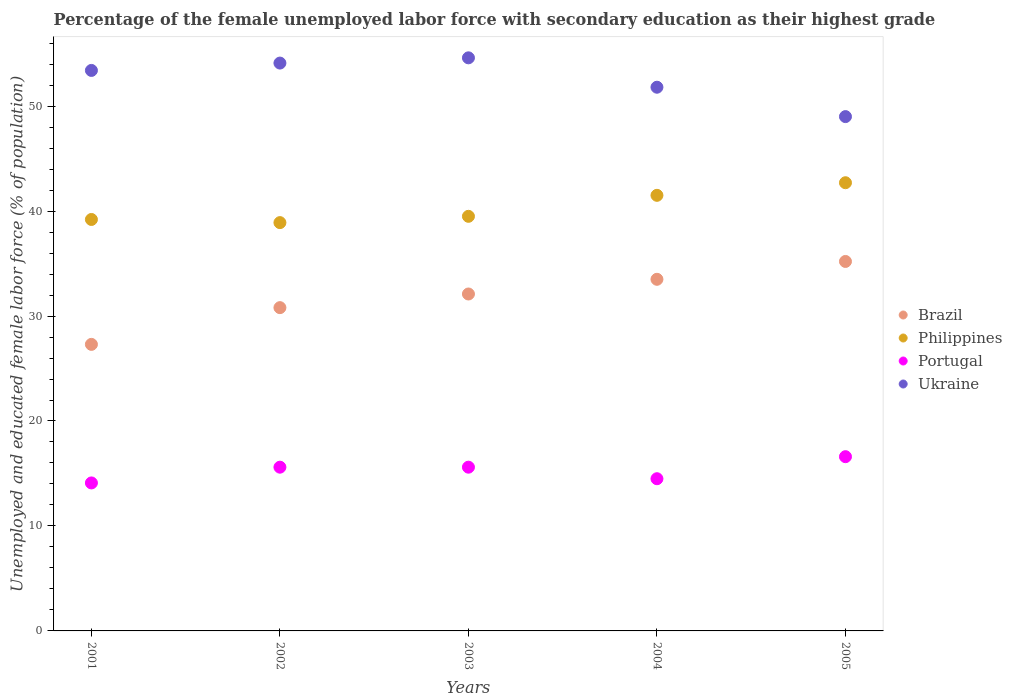How many different coloured dotlines are there?
Your answer should be compact. 4. Is the number of dotlines equal to the number of legend labels?
Provide a short and direct response. Yes. What is the percentage of the unemployed female labor force with secondary education in Philippines in 2005?
Provide a succinct answer. 42.7. Across all years, what is the maximum percentage of the unemployed female labor force with secondary education in Philippines?
Ensure brevity in your answer.  42.7. Across all years, what is the minimum percentage of the unemployed female labor force with secondary education in Brazil?
Ensure brevity in your answer.  27.3. In which year was the percentage of the unemployed female labor force with secondary education in Brazil minimum?
Provide a succinct answer. 2001. What is the total percentage of the unemployed female labor force with secondary education in Philippines in the graph?
Keep it short and to the point. 201.8. What is the difference between the percentage of the unemployed female labor force with secondary education in Portugal in 2003 and that in 2005?
Your answer should be compact. -1. What is the difference between the percentage of the unemployed female labor force with secondary education in Brazil in 2004 and the percentage of the unemployed female labor force with secondary education in Portugal in 2003?
Keep it short and to the point. 17.9. What is the average percentage of the unemployed female labor force with secondary education in Ukraine per year?
Ensure brevity in your answer.  52.58. In the year 2002, what is the difference between the percentage of the unemployed female labor force with secondary education in Portugal and percentage of the unemployed female labor force with secondary education in Philippines?
Your answer should be compact. -23.3. In how many years, is the percentage of the unemployed female labor force with secondary education in Brazil greater than 50 %?
Give a very brief answer. 0. What is the ratio of the percentage of the unemployed female labor force with secondary education in Ukraine in 2003 to that in 2004?
Your answer should be very brief. 1.05. Is the difference between the percentage of the unemployed female labor force with secondary education in Portugal in 2002 and 2003 greater than the difference between the percentage of the unemployed female labor force with secondary education in Philippines in 2002 and 2003?
Keep it short and to the point. Yes. What is the difference between the highest and the second highest percentage of the unemployed female labor force with secondary education in Brazil?
Make the answer very short. 1.7. What is the difference between the highest and the lowest percentage of the unemployed female labor force with secondary education in Brazil?
Make the answer very short. 7.9. Is it the case that in every year, the sum of the percentage of the unemployed female labor force with secondary education in Ukraine and percentage of the unemployed female labor force with secondary education in Brazil  is greater than the sum of percentage of the unemployed female labor force with secondary education in Philippines and percentage of the unemployed female labor force with secondary education in Portugal?
Your answer should be compact. Yes. Is it the case that in every year, the sum of the percentage of the unemployed female labor force with secondary education in Ukraine and percentage of the unemployed female labor force with secondary education in Philippines  is greater than the percentage of the unemployed female labor force with secondary education in Brazil?
Offer a very short reply. Yes. Does the percentage of the unemployed female labor force with secondary education in Portugal monotonically increase over the years?
Provide a short and direct response. No. Is the percentage of the unemployed female labor force with secondary education in Ukraine strictly greater than the percentage of the unemployed female labor force with secondary education in Portugal over the years?
Offer a terse response. Yes. Is the percentage of the unemployed female labor force with secondary education in Portugal strictly less than the percentage of the unemployed female labor force with secondary education in Brazil over the years?
Provide a succinct answer. Yes. How many years are there in the graph?
Make the answer very short. 5. What is the difference between two consecutive major ticks on the Y-axis?
Your answer should be compact. 10. Are the values on the major ticks of Y-axis written in scientific E-notation?
Your response must be concise. No. How many legend labels are there?
Give a very brief answer. 4. How are the legend labels stacked?
Provide a succinct answer. Vertical. What is the title of the graph?
Provide a short and direct response. Percentage of the female unemployed labor force with secondary education as their highest grade. Does "Virgin Islands" appear as one of the legend labels in the graph?
Provide a succinct answer. No. What is the label or title of the X-axis?
Provide a short and direct response. Years. What is the label or title of the Y-axis?
Make the answer very short. Unemployed and educated female labor force (% of population). What is the Unemployed and educated female labor force (% of population) of Brazil in 2001?
Keep it short and to the point. 27.3. What is the Unemployed and educated female labor force (% of population) in Philippines in 2001?
Offer a terse response. 39.2. What is the Unemployed and educated female labor force (% of population) of Portugal in 2001?
Provide a succinct answer. 14.1. What is the Unemployed and educated female labor force (% of population) in Ukraine in 2001?
Provide a short and direct response. 53.4. What is the Unemployed and educated female labor force (% of population) of Brazil in 2002?
Offer a terse response. 30.8. What is the Unemployed and educated female labor force (% of population) in Philippines in 2002?
Your answer should be very brief. 38.9. What is the Unemployed and educated female labor force (% of population) of Portugal in 2002?
Your response must be concise. 15.6. What is the Unemployed and educated female labor force (% of population) in Ukraine in 2002?
Offer a very short reply. 54.1. What is the Unemployed and educated female labor force (% of population) in Brazil in 2003?
Your response must be concise. 32.1. What is the Unemployed and educated female labor force (% of population) of Philippines in 2003?
Provide a succinct answer. 39.5. What is the Unemployed and educated female labor force (% of population) of Portugal in 2003?
Keep it short and to the point. 15.6. What is the Unemployed and educated female labor force (% of population) of Ukraine in 2003?
Keep it short and to the point. 54.6. What is the Unemployed and educated female labor force (% of population) of Brazil in 2004?
Keep it short and to the point. 33.5. What is the Unemployed and educated female labor force (% of population) in Philippines in 2004?
Offer a very short reply. 41.5. What is the Unemployed and educated female labor force (% of population) in Portugal in 2004?
Offer a very short reply. 14.5. What is the Unemployed and educated female labor force (% of population) in Ukraine in 2004?
Offer a terse response. 51.8. What is the Unemployed and educated female labor force (% of population) of Brazil in 2005?
Give a very brief answer. 35.2. What is the Unemployed and educated female labor force (% of population) in Philippines in 2005?
Offer a very short reply. 42.7. What is the Unemployed and educated female labor force (% of population) of Portugal in 2005?
Give a very brief answer. 16.6. Across all years, what is the maximum Unemployed and educated female labor force (% of population) in Brazil?
Keep it short and to the point. 35.2. Across all years, what is the maximum Unemployed and educated female labor force (% of population) in Philippines?
Your answer should be compact. 42.7. Across all years, what is the maximum Unemployed and educated female labor force (% of population) in Portugal?
Offer a terse response. 16.6. Across all years, what is the maximum Unemployed and educated female labor force (% of population) in Ukraine?
Offer a terse response. 54.6. Across all years, what is the minimum Unemployed and educated female labor force (% of population) of Brazil?
Your response must be concise. 27.3. Across all years, what is the minimum Unemployed and educated female labor force (% of population) in Philippines?
Your answer should be very brief. 38.9. Across all years, what is the minimum Unemployed and educated female labor force (% of population) in Portugal?
Give a very brief answer. 14.1. What is the total Unemployed and educated female labor force (% of population) of Brazil in the graph?
Your answer should be very brief. 158.9. What is the total Unemployed and educated female labor force (% of population) of Philippines in the graph?
Offer a terse response. 201.8. What is the total Unemployed and educated female labor force (% of population) in Portugal in the graph?
Offer a very short reply. 76.4. What is the total Unemployed and educated female labor force (% of population) of Ukraine in the graph?
Provide a short and direct response. 262.9. What is the difference between the Unemployed and educated female labor force (% of population) in Brazil in 2001 and that in 2002?
Offer a very short reply. -3.5. What is the difference between the Unemployed and educated female labor force (% of population) in Portugal in 2001 and that in 2002?
Make the answer very short. -1.5. What is the difference between the Unemployed and educated female labor force (% of population) of Ukraine in 2001 and that in 2002?
Offer a terse response. -0.7. What is the difference between the Unemployed and educated female labor force (% of population) in Philippines in 2001 and that in 2003?
Your answer should be compact. -0.3. What is the difference between the Unemployed and educated female labor force (% of population) of Portugal in 2001 and that in 2003?
Give a very brief answer. -1.5. What is the difference between the Unemployed and educated female labor force (% of population) of Philippines in 2001 and that in 2004?
Keep it short and to the point. -2.3. What is the difference between the Unemployed and educated female labor force (% of population) of Ukraine in 2001 and that in 2004?
Offer a terse response. 1.6. What is the difference between the Unemployed and educated female labor force (% of population) of Portugal in 2001 and that in 2005?
Your answer should be compact. -2.5. What is the difference between the Unemployed and educated female labor force (% of population) of Ukraine in 2001 and that in 2005?
Give a very brief answer. 4.4. What is the difference between the Unemployed and educated female labor force (% of population) of Brazil in 2002 and that in 2003?
Offer a terse response. -1.3. What is the difference between the Unemployed and educated female labor force (% of population) of Portugal in 2002 and that in 2004?
Keep it short and to the point. 1.1. What is the difference between the Unemployed and educated female labor force (% of population) of Philippines in 2002 and that in 2005?
Make the answer very short. -3.8. What is the difference between the Unemployed and educated female labor force (% of population) in Brazil in 2003 and that in 2004?
Provide a short and direct response. -1.4. What is the difference between the Unemployed and educated female labor force (% of population) of Philippines in 2003 and that in 2004?
Ensure brevity in your answer.  -2. What is the difference between the Unemployed and educated female labor force (% of population) of Ukraine in 2003 and that in 2004?
Make the answer very short. 2.8. What is the difference between the Unemployed and educated female labor force (% of population) in Brazil in 2003 and that in 2005?
Keep it short and to the point. -3.1. What is the difference between the Unemployed and educated female labor force (% of population) in Philippines in 2004 and that in 2005?
Your answer should be compact. -1.2. What is the difference between the Unemployed and educated female labor force (% of population) of Brazil in 2001 and the Unemployed and educated female labor force (% of population) of Portugal in 2002?
Offer a very short reply. 11.7. What is the difference between the Unemployed and educated female labor force (% of population) in Brazil in 2001 and the Unemployed and educated female labor force (% of population) in Ukraine in 2002?
Provide a succinct answer. -26.8. What is the difference between the Unemployed and educated female labor force (% of population) of Philippines in 2001 and the Unemployed and educated female labor force (% of population) of Portugal in 2002?
Your answer should be very brief. 23.6. What is the difference between the Unemployed and educated female labor force (% of population) of Philippines in 2001 and the Unemployed and educated female labor force (% of population) of Ukraine in 2002?
Give a very brief answer. -14.9. What is the difference between the Unemployed and educated female labor force (% of population) of Portugal in 2001 and the Unemployed and educated female labor force (% of population) of Ukraine in 2002?
Your answer should be compact. -40. What is the difference between the Unemployed and educated female labor force (% of population) in Brazil in 2001 and the Unemployed and educated female labor force (% of population) in Portugal in 2003?
Offer a very short reply. 11.7. What is the difference between the Unemployed and educated female labor force (% of population) in Brazil in 2001 and the Unemployed and educated female labor force (% of population) in Ukraine in 2003?
Your answer should be very brief. -27.3. What is the difference between the Unemployed and educated female labor force (% of population) in Philippines in 2001 and the Unemployed and educated female labor force (% of population) in Portugal in 2003?
Ensure brevity in your answer.  23.6. What is the difference between the Unemployed and educated female labor force (% of population) in Philippines in 2001 and the Unemployed and educated female labor force (% of population) in Ukraine in 2003?
Give a very brief answer. -15.4. What is the difference between the Unemployed and educated female labor force (% of population) in Portugal in 2001 and the Unemployed and educated female labor force (% of population) in Ukraine in 2003?
Offer a terse response. -40.5. What is the difference between the Unemployed and educated female labor force (% of population) of Brazil in 2001 and the Unemployed and educated female labor force (% of population) of Ukraine in 2004?
Give a very brief answer. -24.5. What is the difference between the Unemployed and educated female labor force (% of population) of Philippines in 2001 and the Unemployed and educated female labor force (% of population) of Portugal in 2004?
Ensure brevity in your answer.  24.7. What is the difference between the Unemployed and educated female labor force (% of population) of Portugal in 2001 and the Unemployed and educated female labor force (% of population) of Ukraine in 2004?
Keep it short and to the point. -37.7. What is the difference between the Unemployed and educated female labor force (% of population) of Brazil in 2001 and the Unemployed and educated female labor force (% of population) of Philippines in 2005?
Offer a very short reply. -15.4. What is the difference between the Unemployed and educated female labor force (% of population) of Brazil in 2001 and the Unemployed and educated female labor force (% of population) of Portugal in 2005?
Give a very brief answer. 10.7. What is the difference between the Unemployed and educated female labor force (% of population) of Brazil in 2001 and the Unemployed and educated female labor force (% of population) of Ukraine in 2005?
Keep it short and to the point. -21.7. What is the difference between the Unemployed and educated female labor force (% of population) of Philippines in 2001 and the Unemployed and educated female labor force (% of population) of Portugal in 2005?
Make the answer very short. 22.6. What is the difference between the Unemployed and educated female labor force (% of population) in Philippines in 2001 and the Unemployed and educated female labor force (% of population) in Ukraine in 2005?
Offer a terse response. -9.8. What is the difference between the Unemployed and educated female labor force (% of population) in Portugal in 2001 and the Unemployed and educated female labor force (% of population) in Ukraine in 2005?
Make the answer very short. -34.9. What is the difference between the Unemployed and educated female labor force (% of population) of Brazil in 2002 and the Unemployed and educated female labor force (% of population) of Ukraine in 2003?
Your answer should be compact. -23.8. What is the difference between the Unemployed and educated female labor force (% of population) of Philippines in 2002 and the Unemployed and educated female labor force (% of population) of Portugal in 2003?
Provide a succinct answer. 23.3. What is the difference between the Unemployed and educated female labor force (% of population) of Philippines in 2002 and the Unemployed and educated female labor force (% of population) of Ukraine in 2003?
Make the answer very short. -15.7. What is the difference between the Unemployed and educated female labor force (% of population) of Portugal in 2002 and the Unemployed and educated female labor force (% of population) of Ukraine in 2003?
Keep it short and to the point. -39. What is the difference between the Unemployed and educated female labor force (% of population) of Brazil in 2002 and the Unemployed and educated female labor force (% of population) of Philippines in 2004?
Offer a terse response. -10.7. What is the difference between the Unemployed and educated female labor force (% of population) in Brazil in 2002 and the Unemployed and educated female labor force (% of population) in Portugal in 2004?
Provide a short and direct response. 16.3. What is the difference between the Unemployed and educated female labor force (% of population) in Philippines in 2002 and the Unemployed and educated female labor force (% of population) in Portugal in 2004?
Provide a succinct answer. 24.4. What is the difference between the Unemployed and educated female labor force (% of population) of Portugal in 2002 and the Unemployed and educated female labor force (% of population) of Ukraine in 2004?
Offer a terse response. -36.2. What is the difference between the Unemployed and educated female labor force (% of population) in Brazil in 2002 and the Unemployed and educated female labor force (% of population) in Portugal in 2005?
Your answer should be compact. 14.2. What is the difference between the Unemployed and educated female labor force (% of population) in Brazil in 2002 and the Unemployed and educated female labor force (% of population) in Ukraine in 2005?
Provide a succinct answer. -18.2. What is the difference between the Unemployed and educated female labor force (% of population) in Philippines in 2002 and the Unemployed and educated female labor force (% of population) in Portugal in 2005?
Provide a succinct answer. 22.3. What is the difference between the Unemployed and educated female labor force (% of population) in Philippines in 2002 and the Unemployed and educated female labor force (% of population) in Ukraine in 2005?
Give a very brief answer. -10.1. What is the difference between the Unemployed and educated female labor force (% of population) of Portugal in 2002 and the Unemployed and educated female labor force (% of population) of Ukraine in 2005?
Your answer should be very brief. -33.4. What is the difference between the Unemployed and educated female labor force (% of population) of Brazil in 2003 and the Unemployed and educated female labor force (% of population) of Portugal in 2004?
Your response must be concise. 17.6. What is the difference between the Unemployed and educated female labor force (% of population) of Brazil in 2003 and the Unemployed and educated female labor force (% of population) of Ukraine in 2004?
Your answer should be compact. -19.7. What is the difference between the Unemployed and educated female labor force (% of population) of Philippines in 2003 and the Unemployed and educated female labor force (% of population) of Ukraine in 2004?
Offer a very short reply. -12.3. What is the difference between the Unemployed and educated female labor force (% of population) of Portugal in 2003 and the Unemployed and educated female labor force (% of population) of Ukraine in 2004?
Ensure brevity in your answer.  -36.2. What is the difference between the Unemployed and educated female labor force (% of population) in Brazil in 2003 and the Unemployed and educated female labor force (% of population) in Ukraine in 2005?
Ensure brevity in your answer.  -16.9. What is the difference between the Unemployed and educated female labor force (% of population) of Philippines in 2003 and the Unemployed and educated female labor force (% of population) of Portugal in 2005?
Provide a short and direct response. 22.9. What is the difference between the Unemployed and educated female labor force (% of population) of Portugal in 2003 and the Unemployed and educated female labor force (% of population) of Ukraine in 2005?
Offer a terse response. -33.4. What is the difference between the Unemployed and educated female labor force (% of population) in Brazil in 2004 and the Unemployed and educated female labor force (% of population) in Portugal in 2005?
Offer a very short reply. 16.9. What is the difference between the Unemployed and educated female labor force (% of population) of Brazil in 2004 and the Unemployed and educated female labor force (% of population) of Ukraine in 2005?
Offer a very short reply. -15.5. What is the difference between the Unemployed and educated female labor force (% of population) in Philippines in 2004 and the Unemployed and educated female labor force (% of population) in Portugal in 2005?
Make the answer very short. 24.9. What is the difference between the Unemployed and educated female labor force (% of population) of Portugal in 2004 and the Unemployed and educated female labor force (% of population) of Ukraine in 2005?
Your response must be concise. -34.5. What is the average Unemployed and educated female labor force (% of population) in Brazil per year?
Make the answer very short. 31.78. What is the average Unemployed and educated female labor force (% of population) of Philippines per year?
Provide a short and direct response. 40.36. What is the average Unemployed and educated female labor force (% of population) of Portugal per year?
Your answer should be compact. 15.28. What is the average Unemployed and educated female labor force (% of population) in Ukraine per year?
Offer a terse response. 52.58. In the year 2001, what is the difference between the Unemployed and educated female labor force (% of population) in Brazil and Unemployed and educated female labor force (% of population) in Philippines?
Offer a terse response. -11.9. In the year 2001, what is the difference between the Unemployed and educated female labor force (% of population) in Brazil and Unemployed and educated female labor force (% of population) in Portugal?
Give a very brief answer. 13.2. In the year 2001, what is the difference between the Unemployed and educated female labor force (% of population) of Brazil and Unemployed and educated female labor force (% of population) of Ukraine?
Keep it short and to the point. -26.1. In the year 2001, what is the difference between the Unemployed and educated female labor force (% of population) of Philippines and Unemployed and educated female labor force (% of population) of Portugal?
Provide a succinct answer. 25.1. In the year 2001, what is the difference between the Unemployed and educated female labor force (% of population) in Philippines and Unemployed and educated female labor force (% of population) in Ukraine?
Keep it short and to the point. -14.2. In the year 2001, what is the difference between the Unemployed and educated female labor force (% of population) in Portugal and Unemployed and educated female labor force (% of population) in Ukraine?
Provide a succinct answer. -39.3. In the year 2002, what is the difference between the Unemployed and educated female labor force (% of population) in Brazil and Unemployed and educated female labor force (% of population) in Portugal?
Give a very brief answer. 15.2. In the year 2002, what is the difference between the Unemployed and educated female labor force (% of population) of Brazil and Unemployed and educated female labor force (% of population) of Ukraine?
Ensure brevity in your answer.  -23.3. In the year 2002, what is the difference between the Unemployed and educated female labor force (% of population) in Philippines and Unemployed and educated female labor force (% of population) in Portugal?
Your answer should be compact. 23.3. In the year 2002, what is the difference between the Unemployed and educated female labor force (% of population) of Philippines and Unemployed and educated female labor force (% of population) of Ukraine?
Your answer should be compact. -15.2. In the year 2002, what is the difference between the Unemployed and educated female labor force (% of population) in Portugal and Unemployed and educated female labor force (% of population) in Ukraine?
Provide a succinct answer. -38.5. In the year 2003, what is the difference between the Unemployed and educated female labor force (% of population) in Brazil and Unemployed and educated female labor force (% of population) in Philippines?
Offer a terse response. -7.4. In the year 2003, what is the difference between the Unemployed and educated female labor force (% of population) of Brazil and Unemployed and educated female labor force (% of population) of Portugal?
Keep it short and to the point. 16.5. In the year 2003, what is the difference between the Unemployed and educated female labor force (% of population) in Brazil and Unemployed and educated female labor force (% of population) in Ukraine?
Your response must be concise. -22.5. In the year 2003, what is the difference between the Unemployed and educated female labor force (% of population) of Philippines and Unemployed and educated female labor force (% of population) of Portugal?
Provide a short and direct response. 23.9. In the year 2003, what is the difference between the Unemployed and educated female labor force (% of population) of Philippines and Unemployed and educated female labor force (% of population) of Ukraine?
Your answer should be compact. -15.1. In the year 2003, what is the difference between the Unemployed and educated female labor force (% of population) of Portugal and Unemployed and educated female labor force (% of population) of Ukraine?
Provide a short and direct response. -39. In the year 2004, what is the difference between the Unemployed and educated female labor force (% of population) in Brazil and Unemployed and educated female labor force (% of population) in Ukraine?
Your answer should be compact. -18.3. In the year 2004, what is the difference between the Unemployed and educated female labor force (% of population) of Philippines and Unemployed and educated female labor force (% of population) of Portugal?
Keep it short and to the point. 27. In the year 2004, what is the difference between the Unemployed and educated female labor force (% of population) in Philippines and Unemployed and educated female labor force (% of population) in Ukraine?
Your answer should be very brief. -10.3. In the year 2004, what is the difference between the Unemployed and educated female labor force (% of population) of Portugal and Unemployed and educated female labor force (% of population) of Ukraine?
Give a very brief answer. -37.3. In the year 2005, what is the difference between the Unemployed and educated female labor force (% of population) in Philippines and Unemployed and educated female labor force (% of population) in Portugal?
Keep it short and to the point. 26.1. In the year 2005, what is the difference between the Unemployed and educated female labor force (% of population) in Philippines and Unemployed and educated female labor force (% of population) in Ukraine?
Ensure brevity in your answer.  -6.3. In the year 2005, what is the difference between the Unemployed and educated female labor force (% of population) in Portugal and Unemployed and educated female labor force (% of population) in Ukraine?
Offer a very short reply. -32.4. What is the ratio of the Unemployed and educated female labor force (% of population) in Brazil in 2001 to that in 2002?
Offer a very short reply. 0.89. What is the ratio of the Unemployed and educated female labor force (% of population) in Philippines in 2001 to that in 2002?
Keep it short and to the point. 1.01. What is the ratio of the Unemployed and educated female labor force (% of population) of Portugal in 2001 to that in 2002?
Make the answer very short. 0.9. What is the ratio of the Unemployed and educated female labor force (% of population) of Ukraine in 2001 to that in 2002?
Ensure brevity in your answer.  0.99. What is the ratio of the Unemployed and educated female labor force (% of population) in Brazil in 2001 to that in 2003?
Provide a succinct answer. 0.85. What is the ratio of the Unemployed and educated female labor force (% of population) in Philippines in 2001 to that in 2003?
Provide a succinct answer. 0.99. What is the ratio of the Unemployed and educated female labor force (% of population) in Portugal in 2001 to that in 2003?
Make the answer very short. 0.9. What is the ratio of the Unemployed and educated female labor force (% of population) in Brazil in 2001 to that in 2004?
Offer a terse response. 0.81. What is the ratio of the Unemployed and educated female labor force (% of population) in Philippines in 2001 to that in 2004?
Provide a succinct answer. 0.94. What is the ratio of the Unemployed and educated female labor force (% of population) of Portugal in 2001 to that in 2004?
Provide a short and direct response. 0.97. What is the ratio of the Unemployed and educated female labor force (% of population) in Ukraine in 2001 to that in 2004?
Your response must be concise. 1.03. What is the ratio of the Unemployed and educated female labor force (% of population) in Brazil in 2001 to that in 2005?
Your answer should be compact. 0.78. What is the ratio of the Unemployed and educated female labor force (% of population) of Philippines in 2001 to that in 2005?
Give a very brief answer. 0.92. What is the ratio of the Unemployed and educated female labor force (% of population) in Portugal in 2001 to that in 2005?
Your answer should be very brief. 0.85. What is the ratio of the Unemployed and educated female labor force (% of population) in Ukraine in 2001 to that in 2005?
Keep it short and to the point. 1.09. What is the ratio of the Unemployed and educated female labor force (% of population) in Brazil in 2002 to that in 2003?
Provide a succinct answer. 0.96. What is the ratio of the Unemployed and educated female labor force (% of population) in Brazil in 2002 to that in 2004?
Provide a short and direct response. 0.92. What is the ratio of the Unemployed and educated female labor force (% of population) of Philippines in 2002 to that in 2004?
Offer a terse response. 0.94. What is the ratio of the Unemployed and educated female labor force (% of population) in Portugal in 2002 to that in 2004?
Provide a short and direct response. 1.08. What is the ratio of the Unemployed and educated female labor force (% of population) in Ukraine in 2002 to that in 2004?
Provide a succinct answer. 1.04. What is the ratio of the Unemployed and educated female labor force (% of population) of Philippines in 2002 to that in 2005?
Offer a terse response. 0.91. What is the ratio of the Unemployed and educated female labor force (% of population) in Portugal in 2002 to that in 2005?
Make the answer very short. 0.94. What is the ratio of the Unemployed and educated female labor force (% of population) in Ukraine in 2002 to that in 2005?
Your response must be concise. 1.1. What is the ratio of the Unemployed and educated female labor force (% of population) of Brazil in 2003 to that in 2004?
Ensure brevity in your answer.  0.96. What is the ratio of the Unemployed and educated female labor force (% of population) of Philippines in 2003 to that in 2004?
Ensure brevity in your answer.  0.95. What is the ratio of the Unemployed and educated female labor force (% of population) in Portugal in 2003 to that in 2004?
Provide a short and direct response. 1.08. What is the ratio of the Unemployed and educated female labor force (% of population) of Ukraine in 2003 to that in 2004?
Your answer should be very brief. 1.05. What is the ratio of the Unemployed and educated female labor force (% of population) in Brazil in 2003 to that in 2005?
Offer a very short reply. 0.91. What is the ratio of the Unemployed and educated female labor force (% of population) in Philippines in 2003 to that in 2005?
Give a very brief answer. 0.93. What is the ratio of the Unemployed and educated female labor force (% of population) of Portugal in 2003 to that in 2005?
Make the answer very short. 0.94. What is the ratio of the Unemployed and educated female labor force (% of population) in Ukraine in 2003 to that in 2005?
Provide a short and direct response. 1.11. What is the ratio of the Unemployed and educated female labor force (% of population) of Brazil in 2004 to that in 2005?
Make the answer very short. 0.95. What is the ratio of the Unemployed and educated female labor force (% of population) in Philippines in 2004 to that in 2005?
Give a very brief answer. 0.97. What is the ratio of the Unemployed and educated female labor force (% of population) of Portugal in 2004 to that in 2005?
Your response must be concise. 0.87. What is the ratio of the Unemployed and educated female labor force (% of population) in Ukraine in 2004 to that in 2005?
Offer a very short reply. 1.06. What is the difference between the highest and the second highest Unemployed and educated female labor force (% of population) of Brazil?
Ensure brevity in your answer.  1.7. What is the difference between the highest and the second highest Unemployed and educated female labor force (% of population) in Philippines?
Offer a terse response. 1.2. What is the difference between the highest and the second highest Unemployed and educated female labor force (% of population) in Portugal?
Make the answer very short. 1. What is the difference between the highest and the second highest Unemployed and educated female labor force (% of population) of Ukraine?
Provide a short and direct response. 0.5. What is the difference between the highest and the lowest Unemployed and educated female labor force (% of population) of Brazil?
Offer a terse response. 7.9. 